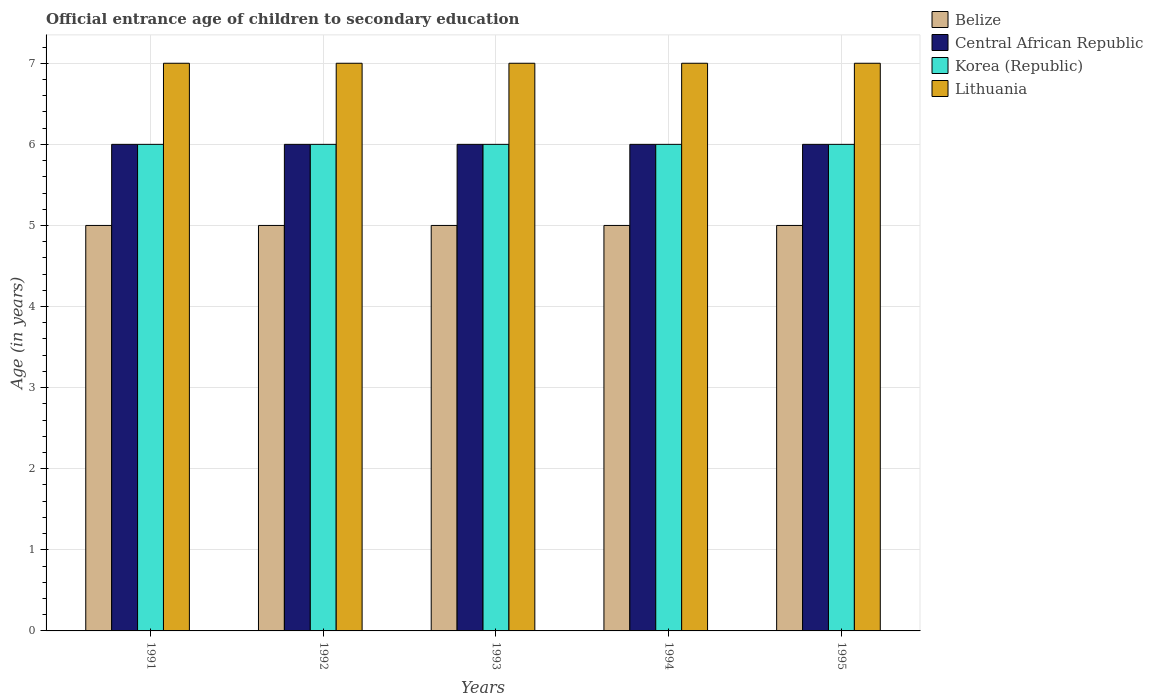Across all years, what is the maximum secondary school starting age of children in Belize?
Keep it short and to the point. 5. Across all years, what is the minimum secondary school starting age of children in Belize?
Provide a succinct answer. 5. In which year was the secondary school starting age of children in Lithuania maximum?
Ensure brevity in your answer.  1991. What is the total secondary school starting age of children in Central African Republic in the graph?
Provide a succinct answer. 30. Is the secondary school starting age of children in Korea (Republic) in 1992 less than that in 1994?
Keep it short and to the point. No. What is the difference between the highest and the second highest secondary school starting age of children in Central African Republic?
Your answer should be very brief. 0. What is the difference between the highest and the lowest secondary school starting age of children in Lithuania?
Provide a succinct answer. 0. Is it the case that in every year, the sum of the secondary school starting age of children in Lithuania and secondary school starting age of children in Central African Republic is greater than the sum of secondary school starting age of children in Belize and secondary school starting age of children in Korea (Republic)?
Your response must be concise. Yes. What does the 2nd bar from the left in 1992 represents?
Your response must be concise. Central African Republic. What does the 2nd bar from the right in 1994 represents?
Make the answer very short. Korea (Republic). How many bars are there?
Provide a succinct answer. 20. How many years are there in the graph?
Your answer should be compact. 5. Are the values on the major ticks of Y-axis written in scientific E-notation?
Your response must be concise. No. Does the graph contain any zero values?
Keep it short and to the point. No. Does the graph contain grids?
Your response must be concise. Yes. Where does the legend appear in the graph?
Make the answer very short. Top right. What is the title of the graph?
Make the answer very short. Official entrance age of children to secondary education. What is the label or title of the Y-axis?
Offer a very short reply. Age (in years). What is the Age (in years) of Central African Republic in 1991?
Your answer should be very brief. 6. What is the Age (in years) of Korea (Republic) in 1991?
Your response must be concise. 6. What is the Age (in years) of Lithuania in 1991?
Provide a succinct answer. 7. What is the Age (in years) of Lithuania in 1992?
Your answer should be very brief. 7. What is the Age (in years) in Lithuania in 1993?
Offer a terse response. 7. What is the Age (in years) in Korea (Republic) in 1994?
Your response must be concise. 6. What is the Age (in years) of Belize in 1995?
Provide a succinct answer. 5. What is the Age (in years) of Central African Republic in 1995?
Offer a terse response. 6. What is the Age (in years) of Korea (Republic) in 1995?
Offer a very short reply. 6. What is the Age (in years) of Lithuania in 1995?
Provide a short and direct response. 7. Across all years, what is the maximum Age (in years) of Lithuania?
Offer a very short reply. 7. Across all years, what is the minimum Age (in years) in Belize?
Your answer should be compact. 5. Across all years, what is the minimum Age (in years) of Korea (Republic)?
Give a very brief answer. 6. Across all years, what is the minimum Age (in years) in Lithuania?
Offer a terse response. 7. What is the total Age (in years) of Belize in the graph?
Your response must be concise. 25. What is the total Age (in years) in Central African Republic in the graph?
Keep it short and to the point. 30. What is the total Age (in years) in Korea (Republic) in the graph?
Offer a terse response. 30. What is the difference between the Age (in years) of Lithuania in 1991 and that in 1992?
Offer a terse response. 0. What is the difference between the Age (in years) in Central African Republic in 1991 and that in 1993?
Ensure brevity in your answer.  0. What is the difference between the Age (in years) in Lithuania in 1991 and that in 1993?
Offer a terse response. 0. What is the difference between the Age (in years) in Belize in 1991 and that in 1994?
Make the answer very short. 0. What is the difference between the Age (in years) in Central African Republic in 1991 and that in 1994?
Offer a very short reply. 0. What is the difference between the Age (in years) of Korea (Republic) in 1991 and that in 1994?
Make the answer very short. 0. What is the difference between the Age (in years) in Lithuania in 1991 and that in 1994?
Provide a succinct answer. 0. What is the difference between the Age (in years) in Belize in 1991 and that in 1995?
Make the answer very short. 0. What is the difference between the Age (in years) in Central African Republic in 1991 and that in 1995?
Ensure brevity in your answer.  0. What is the difference between the Age (in years) in Belize in 1992 and that in 1993?
Offer a terse response. 0. What is the difference between the Age (in years) of Central African Republic in 1992 and that in 1993?
Keep it short and to the point. 0. What is the difference between the Age (in years) in Belize in 1992 and that in 1994?
Offer a terse response. 0. What is the difference between the Age (in years) in Central African Republic in 1992 and that in 1994?
Give a very brief answer. 0. What is the difference between the Age (in years) in Korea (Republic) in 1992 and that in 1995?
Your answer should be very brief. 0. What is the difference between the Age (in years) of Lithuania in 1992 and that in 1995?
Ensure brevity in your answer.  0. What is the difference between the Age (in years) in Lithuania in 1993 and that in 1994?
Provide a succinct answer. 0. What is the difference between the Age (in years) of Belize in 1993 and that in 1995?
Offer a very short reply. 0. What is the difference between the Age (in years) in Korea (Republic) in 1993 and that in 1995?
Ensure brevity in your answer.  0. What is the difference between the Age (in years) of Belize in 1994 and that in 1995?
Your answer should be very brief. 0. What is the difference between the Age (in years) of Korea (Republic) in 1994 and that in 1995?
Your answer should be very brief. 0. What is the difference between the Age (in years) in Central African Republic in 1991 and the Age (in years) in Lithuania in 1992?
Provide a succinct answer. -1. What is the difference between the Age (in years) of Belize in 1991 and the Age (in years) of Korea (Republic) in 1993?
Provide a short and direct response. -1. What is the difference between the Age (in years) of Central African Republic in 1991 and the Age (in years) of Lithuania in 1993?
Offer a very short reply. -1. What is the difference between the Age (in years) in Belize in 1991 and the Age (in years) in Korea (Republic) in 1995?
Ensure brevity in your answer.  -1. What is the difference between the Age (in years) in Korea (Republic) in 1991 and the Age (in years) in Lithuania in 1995?
Your answer should be compact. -1. What is the difference between the Age (in years) of Belize in 1992 and the Age (in years) of Central African Republic in 1993?
Provide a succinct answer. -1. What is the difference between the Age (in years) of Belize in 1992 and the Age (in years) of Korea (Republic) in 1993?
Ensure brevity in your answer.  -1. What is the difference between the Age (in years) of Belize in 1992 and the Age (in years) of Lithuania in 1993?
Make the answer very short. -2. What is the difference between the Age (in years) in Belize in 1992 and the Age (in years) in Central African Republic in 1994?
Offer a terse response. -1. What is the difference between the Age (in years) of Belize in 1992 and the Age (in years) of Lithuania in 1994?
Offer a terse response. -2. What is the difference between the Age (in years) in Central African Republic in 1992 and the Age (in years) in Korea (Republic) in 1994?
Make the answer very short. 0. What is the difference between the Age (in years) of Central African Republic in 1992 and the Age (in years) of Lithuania in 1994?
Keep it short and to the point. -1. What is the difference between the Age (in years) in Belize in 1992 and the Age (in years) in Central African Republic in 1995?
Ensure brevity in your answer.  -1. What is the difference between the Age (in years) of Belize in 1992 and the Age (in years) of Lithuania in 1995?
Your answer should be compact. -2. What is the difference between the Age (in years) in Central African Republic in 1992 and the Age (in years) in Korea (Republic) in 1995?
Your answer should be compact. 0. What is the difference between the Age (in years) of Central African Republic in 1992 and the Age (in years) of Lithuania in 1995?
Offer a very short reply. -1. What is the difference between the Age (in years) in Belize in 1993 and the Age (in years) in Central African Republic in 1995?
Give a very brief answer. -1. What is the difference between the Age (in years) of Central African Republic in 1993 and the Age (in years) of Lithuania in 1995?
Offer a very short reply. -1. What is the difference between the Age (in years) of Belize in 1994 and the Age (in years) of Korea (Republic) in 1995?
Provide a succinct answer. -1. What is the difference between the Age (in years) in Central African Republic in 1994 and the Age (in years) in Lithuania in 1995?
Offer a terse response. -1. What is the difference between the Age (in years) of Korea (Republic) in 1994 and the Age (in years) of Lithuania in 1995?
Provide a short and direct response. -1. In the year 1991, what is the difference between the Age (in years) in Belize and Age (in years) in Korea (Republic)?
Give a very brief answer. -1. In the year 1991, what is the difference between the Age (in years) in Central African Republic and Age (in years) in Lithuania?
Offer a terse response. -1. In the year 1991, what is the difference between the Age (in years) in Korea (Republic) and Age (in years) in Lithuania?
Your response must be concise. -1. In the year 1992, what is the difference between the Age (in years) in Central African Republic and Age (in years) in Korea (Republic)?
Offer a terse response. 0. In the year 1992, what is the difference between the Age (in years) in Central African Republic and Age (in years) in Lithuania?
Provide a succinct answer. -1. In the year 1992, what is the difference between the Age (in years) in Korea (Republic) and Age (in years) in Lithuania?
Offer a very short reply. -1. In the year 1993, what is the difference between the Age (in years) in Belize and Age (in years) in Lithuania?
Keep it short and to the point. -2. In the year 1993, what is the difference between the Age (in years) of Korea (Republic) and Age (in years) of Lithuania?
Your answer should be very brief. -1. In the year 1994, what is the difference between the Age (in years) of Belize and Age (in years) of Central African Republic?
Your answer should be compact. -1. In the year 1994, what is the difference between the Age (in years) of Central African Republic and Age (in years) of Korea (Republic)?
Provide a short and direct response. 0. In the year 1994, what is the difference between the Age (in years) in Korea (Republic) and Age (in years) in Lithuania?
Your answer should be very brief. -1. In the year 1995, what is the difference between the Age (in years) in Belize and Age (in years) in Central African Republic?
Provide a short and direct response. -1. In the year 1995, what is the difference between the Age (in years) in Belize and Age (in years) in Lithuania?
Give a very brief answer. -2. In the year 1995, what is the difference between the Age (in years) in Central African Republic and Age (in years) in Korea (Republic)?
Your response must be concise. 0. In the year 1995, what is the difference between the Age (in years) in Korea (Republic) and Age (in years) in Lithuania?
Ensure brevity in your answer.  -1. What is the ratio of the Age (in years) of Belize in 1991 to that in 1992?
Give a very brief answer. 1. What is the ratio of the Age (in years) in Belize in 1991 to that in 1993?
Give a very brief answer. 1. What is the ratio of the Age (in years) in Korea (Republic) in 1991 to that in 1993?
Keep it short and to the point. 1. What is the ratio of the Age (in years) of Lithuania in 1991 to that in 1993?
Offer a terse response. 1. What is the ratio of the Age (in years) of Korea (Republic) in 1991 to that in 1994?
Provide a short and direct response. 1. What is the ratio of the Age (in years) of Central African Republic in 1992 to that in 1993?
Provide a succinct answer. 1. What is the ratio of the Age (in years) of Lithuania in 1992 to that in 1993?
Make the answer very short. 1. What is the ratio of the Age (in years) in Central African Republic in 1992 to that in 1994?
Your response must be concise. 1. What is the ratio of the Age (in years) of Lithuania in 1992 to that in 1995?
Your answer should be compact. 1. What is the ratio of the Age (in years) of Belize in 1993 to that in 1994?
Offer a very short reply. 1. What is the ratio of the Age (in years) of Korea (Republic) in 1993 to that in 1994?
Your response must be concise. 1. What is the ratio of the Age (in years) in Belize in 1994 to that in 1995?
Give a very brief answer. 1. What is the ratio of the Age (in years) of Korea (Republic) in 1994 to that in 1995?
Your response must be concise. 1. What is the difference between the highest and the second highest Age (in years) of Korea (Republic)?
Offer a very short reply. 0. What is the difference between the highest and the lowest Age (in years) of Belize?
Provide a succinct answer. 0. What is the difference between the highest and the lowest Age (in years) of Central African Republic?
Your response must be concise. 0. What is the difference between the highest and the lowest Age (in years) of Lithuania?
Offer a very short reply. 0. 